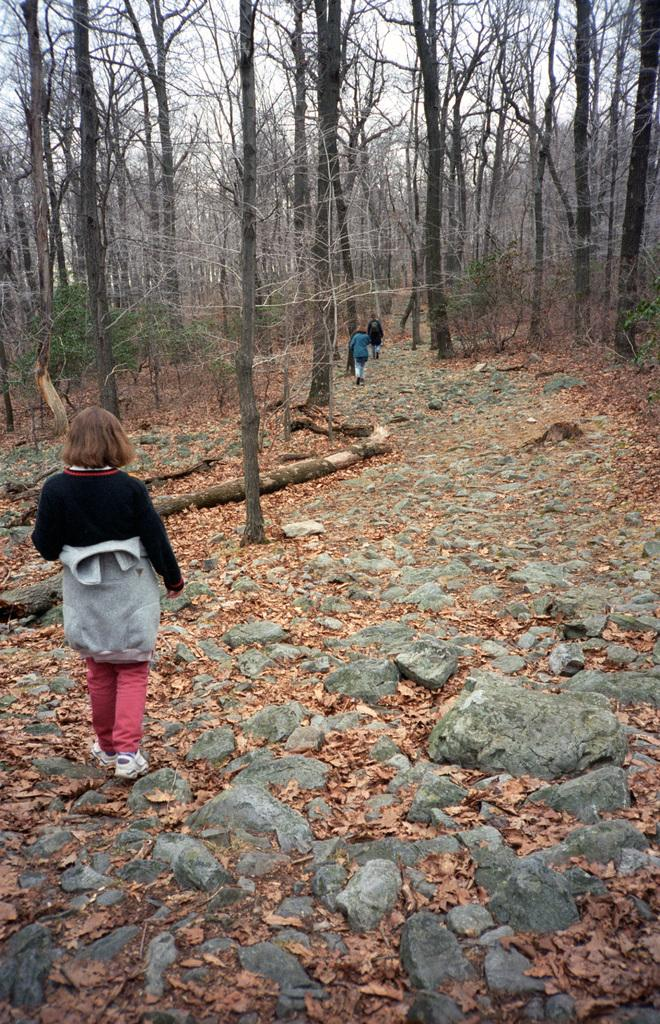What type of vegetation can be seen in the image? There are trees in the image. What part of the natural environment is visible in the image? The sky is visible in the background of the image. What type of blood vessels can be seen in the trees in the image? There are no blood vessels visible in the trees in the image, as trees do not have blood vessels. 